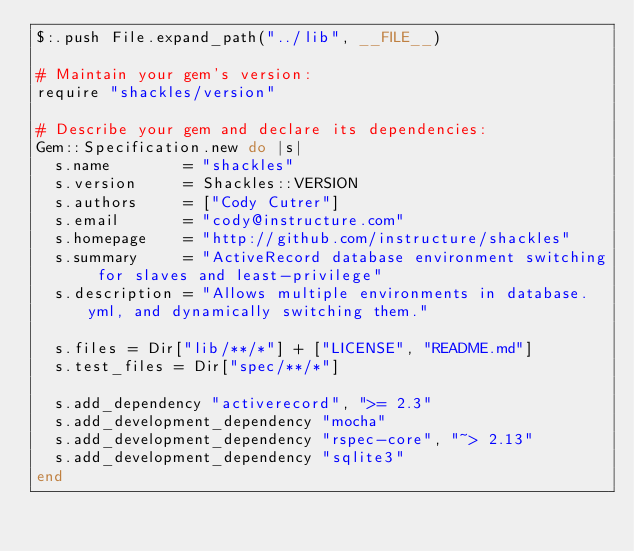<code> <loc_0><loc_0><loc_500><loc_500><_Ruby_>$:.push File.expand_path("../lib", __FILE__)

# Maintain your gem's version:
require "shackles/version"

# Describe your gem and declare its dependencies:
Gem::Specification.new do |s|
  s.name        = "shackles"
  s.version     = Shackles::VERSION
  s.authors     = ["Cody Cutrer"]
  s.email       = "cody@instructure.com"
  s.homepage    = "http://github.com/instructure/shackles"
  s.summary     = "ActiveRecord database environment switching for slaves and least-privilege"
  s.description = "Allows multiple environments in database.yml, and dynamically switching them."

  s.files = Dir["lib/**/*"] + ["LICENSE", "README.md"]
  s.test_files = Dir["spec/**/*"]

  s.add_dependency "activerecord", ">= 2.3"
  s.add_development_dependency "mocha"
  s.add_development_dependency "rspec-core", "~> 2.13"
  s.add_development_dependency "sqlite3"
end
</code> 